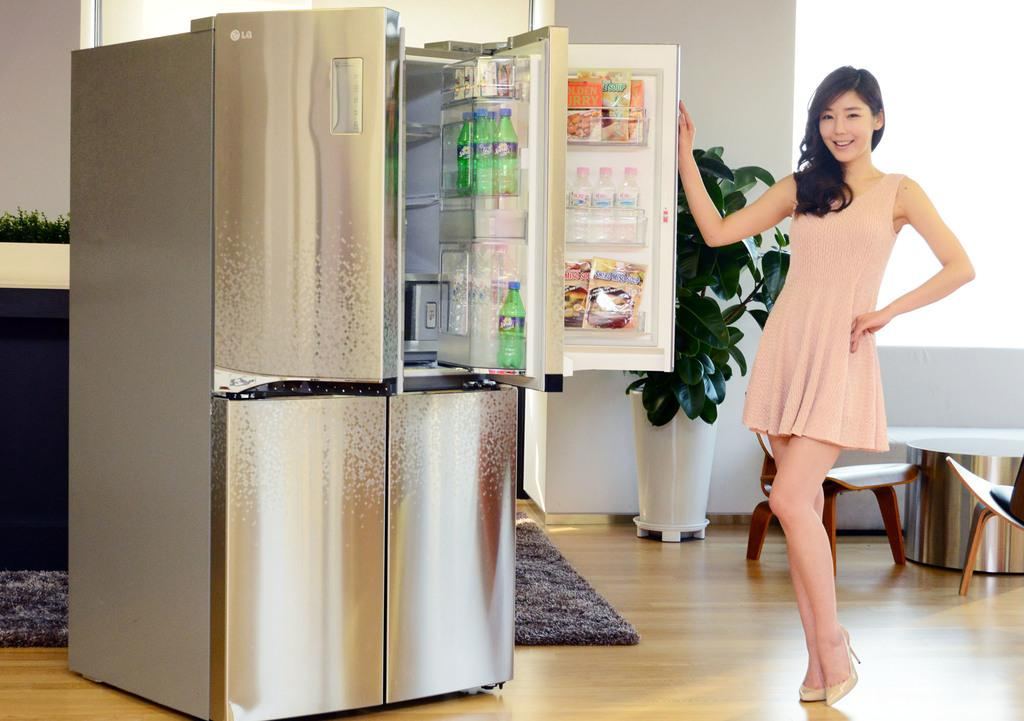<image>
Relay a brief, clear account of the picture shown. Several bottles of Sprite are located on the door of the LG refrigerator. 